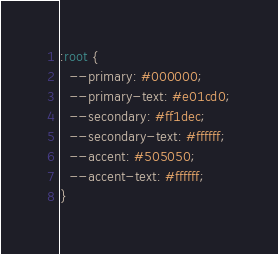<code> <loc_0><loc_0><loc_500><loc_500><_CSS_>:root {
  --primary: #000000;
  --primary-text: #e01cd0;
  --secondary: #ff1dec;
  --secondary-text: #ffffff;
  --accent: #505050;
  --accent-text: #ffffff;
}
</code> 